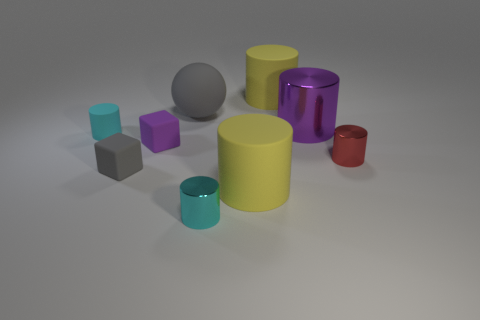Subtract all red shiny cylinders. How many cylinders are left? 5 Subtract all yellow cylinders. How many cylinders are left? 4 Subtract all balls. How many objects are left? 8 Subtract 3 cylinders. How many cylinders are left? 3 Add 1 gray matte things. How many objects exist? 10 Subtract all cyan cylinders. How many yellow spheres are left? 0 Subtract all cubes. Subtract all tiny cyan things. How many objects are left? 5 Add 8 large yellow matte cylinders. How many large yellow matte cylinders are left? 10 Add 3 yellow matte cylinders. How many yellow matte cylinders exist? 5 Subtract 1 gray cubes. How many objects are left? 8 